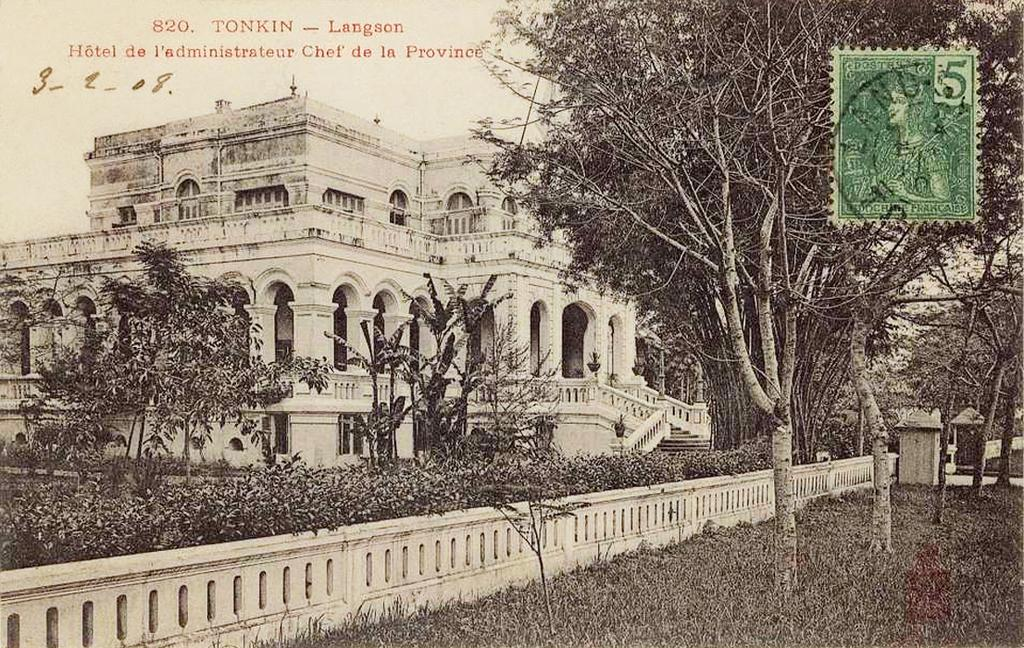What is the color scheme of the image? The image is black and white. What type of natural elements can be seen in the image? There are trees, plants, and grassy land in the image. What type of man-made structure is present in the image? There is a building in the image. What type of barrier can be seen in the image? There is fencing in the image. What additional elements are present at the top of the image? There is text and a stamp at the top of the image. How many circles are visible in the image? There are no circles visible in the image. What type of houses can be seen in the image? There are no houses present in the image. 